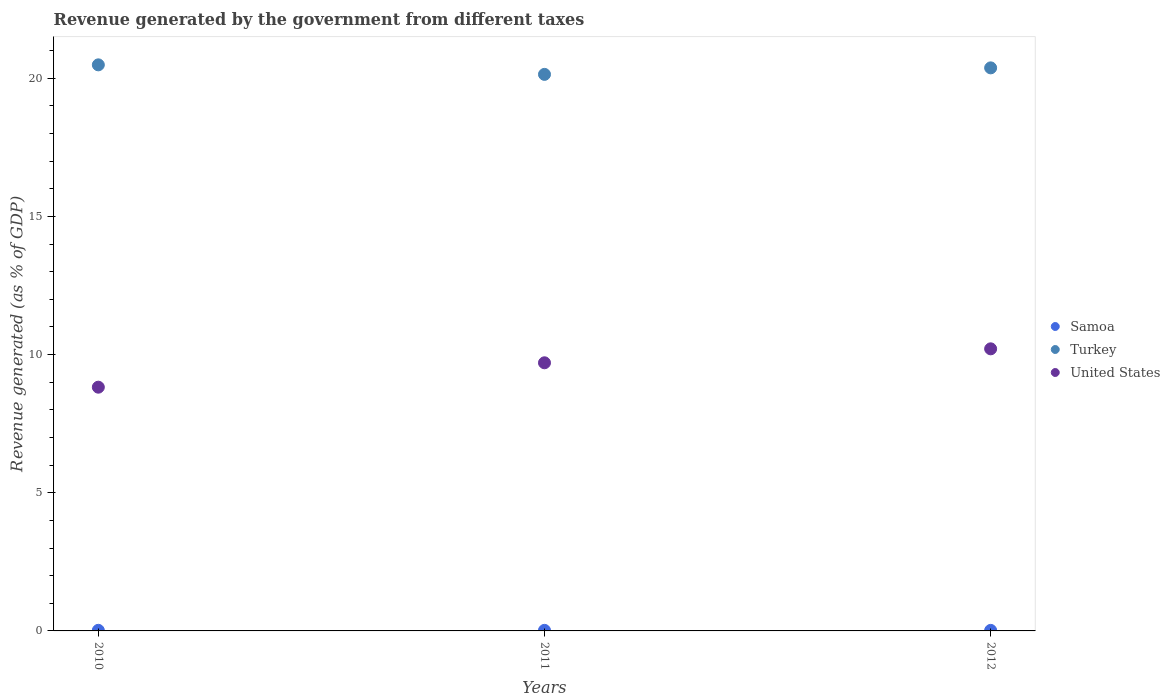What is the revenue generated by the government in Samoa in 2012?
Your answer should be compact. 0.02. Across all years, what is the maximum revenue generated by the government in United States?
Your response must be concise. 10.21. Across all years, what is the minimum revenue generated by the government in United States?
Give a very brief answer. 8.82. In which year was the revenue generated by the government in Samoa maximum?
Provide a short and direct response. 2010. In which year was the revenue generated by the government in United States minimum?
Ensure brevity in your answer.  2010. What is the total revenue generated by the government in United States in the graph?
Your response must be concise. 28.73. What is the difference between the revenue generated by the government in Turkey in 2010 and that in 2011?
Make the answer very short. 0.34. What is the difference between the revenue generated by the government in Turkey in 2011 and the revenue generated by the government in United States in 2010?
Your answer should be compact. 11.32. What is the average revenue generated by the government in United States per year?
Make the answer very short. 9.58. In the year 2011, what is the difference between the revenue generated by the government in United States and revenue generated by the government in Samoa?
Provide a succinct answer. 9.68. What is the ratio of the revenue generated by the government in Samoa in 2010 to that in 2012?
Provide a short and direct response. 1.11. Is the difference between the revenue generated by the government in United States in 2010 and 2011 greater than the difference between the revenue generated by the government in Samoa in 2010 and 2011?
Your answer should be compact. No. What is the difference between the highest and the second highest revenue generated by the government in Turkey?
Give a very brief answer. 0.11. What is the difference between the highest and the lowest revenue generated by the government in United States?
Your response must be concise. 1.39. Is the sum of the revenue generated by the government in United States in 2010 and 2012 greater than the maximum revenue generated by the government in Samoa across all years?
Your response must be concise. Yes. How many dotlines are there?
Your answer should be compact. 3. What is the difference between two consecutive major ticks on the Y-axis?
Offer a terse response. 5. Does the graph contain any zero values?
Ensure brevity in your answer.  No. Where does the legend appear in the graph?
Make the answer very short. Center right. How many legend labels are there?
Provide a succinct answer. 3. What is the title of the graph?
Offer a terse response. Revenue generated by the government from different taxes. What is the label or title of the X-axis?
Provide a succinct answer. Years. What is the label or title of the Y-axis?
Provide a short and direct response. Revenue generated (as % of GDP). What is the Revenue generated (as % of GDP) of Samoa in 2010?
Provide a short and direct response. 0.02. What is the Revenue generated (as % of GDP) of Turkey in 2010?
Provide a succinct answer. 20.49. What is the Revenue generated (as % of GDP) of United States in 2010?
Your answer should be very brief. 8.82. What is the Revenue generated (as % of GDP) in Samoa in 2011?
Provide a short and direct response. 0.02. What is the Revenue generated (as % of GDP) of Turkey in 2011?
Your answer should be compact. 20.14. What is the Revenue generated (as % of GDP) of United States in 2011?
Provide a short and direct response. 9.7. What is the Revenue generated (as % of GDP) of Samoa in 2012?
Give a very brief answer. 0.02. What is the Revenue generated (as % of GDP) of Turkey in 2012?
Make the answer very short. 20.38. What is the Revenue generated (as % of GDP) of United States in 2012?
Your answer should be very brief. 10.21. Across all years, what is the maximum Revenue generated (as % of GDP) in Samoa?
Offer a terse response. 0.02. Across all years, what is the maximum Revenue generated (as % of GDP) in Turkey?
Provide a succinct answer. 20.49. Across all years, what is the maximum Revenue generated (as % of GDP) of United States?
Offer a very short reply. 10.21. Across all years, what is the minimum Revenue generated (as % of GDP) of Samoa?
Ensure brevity in your answer.  0.02. Across all years, what is the minimum Revenue generated (as % of GDP) in Turkey?
Make the answer very short. 20.14. Across all years, what is the minimum Revenue generated (as % of GDP) of United States?
Offer a very short reply. 8.82. What is the total Revenue generated (as % of GDP) of Samoa in the graph?
Provide a short and direct response. 0.06. What is the total Revenue generated (as % of GDP) in Turkey in the graph?
Your answer should be very brief. 61.01. What is the total Revenue generated (as % of GDP) of United States in the graph?
Provide a succinct answer. 28.73. What is the difference between the Revenue generated (as % of GDP) in Samoa in 2010 and that in 2011?
Provide a short and direct response. 0. What is the difference between the Revenue generated (as % of GDP) in Turkey in 2010 and that in 2011?
Your answer should be very brief. 0.34. What is the difference between the Revenue generated (as % of GDP) in United States in 2010 and that in 2011?
Provide a succinct answer. -0.88. What is the difference between the Revenue generated (as % of GDP) in Samoa in 2010 and that in 2012?
Ensure brevity in your answer.  0. What is the difference between the Revenue generated (as % of GDP) of Turkey in 2010 and that in 2012?
Offer a terse response. 0.11. What is the difference between the Revenue generated (as % of GDP) of United States in 2010 and that in 2012?
Provide a short and direct response. -1.39. What is the difference between the Revenue generated (as % of GDP) in Samoa in 2011 and that in 2012?
Keep it short and to the point. 0. What is the difference between the Revenue generated (as % of GDP) in Turkey in 2011 and that in 2012?
Keep it short and to the point. -0.24. What is the difference between the Revenue generated (as % of GDP) in United States in 2011 and that in 2012?
Your response must be concise. -0.51. What is the difference between the Revenue generated (as % of GDP) in Samoa in 2010 and the Revenue generated (as % of GDP) in Turkey in 2011?
Make the answer very short. -20.12. What is the difference between the Revenue generated (as % of GDP) in Samoa in 2010 and the Revenue generated (as % of GDP) in United States in 2011?
Keep it short and to the point. -9.68. What is the difference between the Revenue generated (as % of GDP) in Turkey in 2010 and the Revenue generated (as % of GDP) in United States in 2011?
Make the answer very short. 10.78. What is the difference between the Revenue generated (as % of GDP) of Samoa in 2010 and the Revenue generated (as % of GDP) of Turkey in 2012?
Your answer should be very brief. -20.36. What is the difference between the Revenue generated (as % of GDP) of Samoa in 2010 and the Revenue generated (as % of GDP) of United States in 2012?
Provide a succinct answer. -10.19. What is the difference between the Revenue generated (as % of GDP) in Turkey in 2010 and the Revenue generated (as % of GDP) in United States in 2012?
Ensure brevity in your answer.  10.28. What is the difference between the Revenue generated (as % of GDP) in Samoa in 2011 and the Revenue generated (as % of GDP) in Turkey in 2012?
Keep it short and to the point. -20.36. What is the difference between the Revenue generated (as % of GDP) of Samoa in 2011 and the Revenue generated (as % of GDP) of United States in 2012?
Your response must be concise. -10.19. What is the difference between the Revenue generated (as % of GDP) in Turkey in 2011 and the Revenue generated (as % of GDP) in United States in 2012?
Your response must be concise. 9.93. What is the average Revenue generated (as % of GDP) of Samoa per year?
Make the answer very short. 0.02. What is the average Revenue generated (as % of GDP) in Turkey per year?
Ensure brevity in your answer.  20.34. What is the average Revenue generated (as % of GDP) of United States per year?
Offer a terse response. 9.58. In the year 2010, what is the difference between the Revenue generated (as % of GDP) in Samoa and Revenue generated (as % of GDP) in Turkey?
Offer a very short reply. -20.46. In the year 2010, what is the difference between the Revenue generated (as % of GDP) of Samoa and Revenue generated (as % of GDP) of United States?
Give a very brief answer. -8.8. In the year 2010, what is the difference between the Revenue generated (as % of GDP) of Turkey and Revenue generated (as % of GDP) of United States?
Offer a very short reply. 11.67. In the year 2011, what is the difference between the Revenue generated (as % of GDP) of Samoa and Revenue generated (as % of GDP) of Turkey?
Ensure brevity in your answer.  -20.12. In the year 2011, what is the difference between the Revenue generated (as % of GDP) in Samoa and Revenue generated (as % of GDP) in United States?
Make the answer very short. -9.68. In the year 2011, what is the difference between the Revenue generated (as % of GDP) in Turkey and Revenue generated (as % of GDP) in United States?
Ensure brevity in your answer.  10.44. In the year 2012, what is the difference between the Revenue generated (as % of GDP) of Samoa and Revenue generated (as % of GDP) of Turkey?
Your response must be concise. -20.36. In the year 2012, what is the difference between the Revenue generated (as % of GDP) in Samoa and Revenue generated (as % of GDP) in United States?
Keep it short and to the point. -10.19. In the year 2012, what is the difference between the Revenue generated (as % of GDP) in Turkey and Revenue generated (as % of GDP) in United States?
Your answer should be very brief. 10.17. What is the ratio of the Revenue generated (as % of GDP) of Samoa in 2010 to that in 2011?
Your answer should be compact. 1.06. What is the ratio of the Revenue generated (as % of GDP) of Turkey in 2010 to that in 2011?
Keep it short and to the point. 1.02. What is the ratio of the Revenue generated (as % of GDP) of United States in 2010 to that in 2011?
Offer a very short reply. 0.91. What is the ratio of the Revenue generated (as % of GDP) of Samoa in 2010 to that in 2012?
Provide a succinct answer. 1.11. What is the ratio of the Revenue generated (as % of GDP) of Turkey in 2010 to that in 2012?
Keep it short and to the point. 1.01. What is the ratio of the Revenue generated (as % of GDP) of United States in 2010 to that in 2012?
Your answer should be very brief. 0.86. What is the ratio of the Revenue generated (as % of GDP) in Samoa in 2011 to that in 2012?
Offer a very short reply. 1.05. What is the ratio of the Revenue generated (as % of GDP) of Turkey in 2011 to that in 2012?
Your answer should be very brief. 0.99. What is the ratio of the Revenue generated (as % of GDP) of United States in 2011 to that in 2012?
Make the answer very short. 0.95. What is the difference between the highest and the second highest Revenue generated (as % of GDP) in Samoa?
Offer a very short reply. 0. What is the difference between the highest and the second highest Revenue generated (as % of GDP) of Turkey?
Your answer should be compact. 0.11. What is the difference between the highest and the second highest Revenue generated (as % of GDP) in United States?
Offer a very short reply. 0.51. What is the difference between the highest and the lowest Revenue generated (as % of GDP) in Samoa?
Make the answer very short. 0. What is the difference between the highest and the lowest Revenue generated (as % of GDP) of Turkey?
Offer a terse response. 0.34. What is the difference between the highest and the lowest Revenue generated (as % of GDP) in United States?
Ensure brevity in your answer.  1.39. 